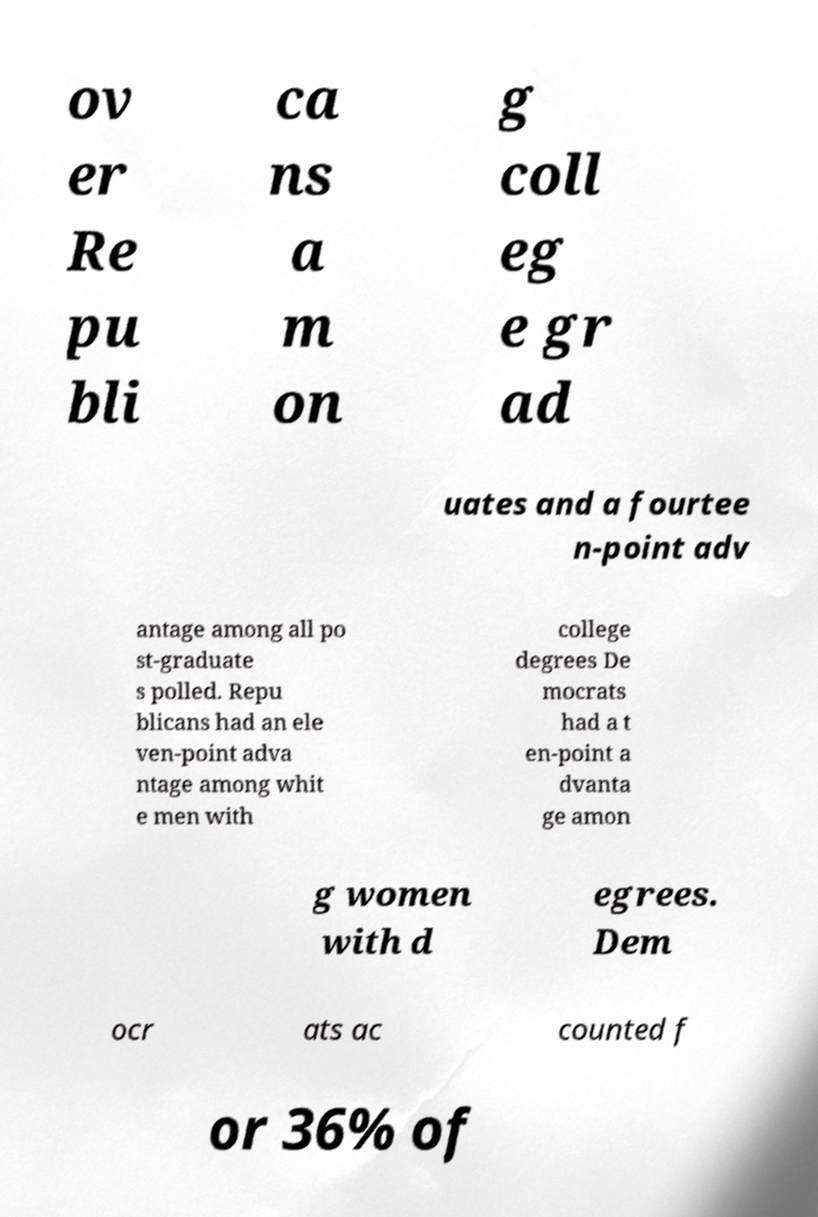I need the written content from this picture converted into text. Can you do that? ov er Re pu bli ca ns a m on g coll eg e gr ad uates and a fourtee n-point adv antage among all po st-graduate s polled. Repu blicans had an ele ven-point adva ntage among whit e men with college degrees De mocrats had a t en-point a dvanta ge amon g women with d egrees. Dem ocr ats ac counted f or 36% of 